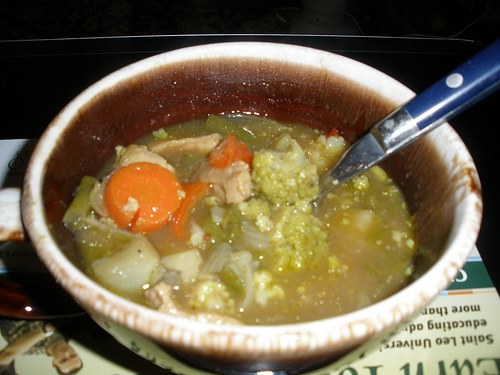How are the vegetables to the left of the soup the veggies are in called? The vegetables to the left of the soup are called onions. 